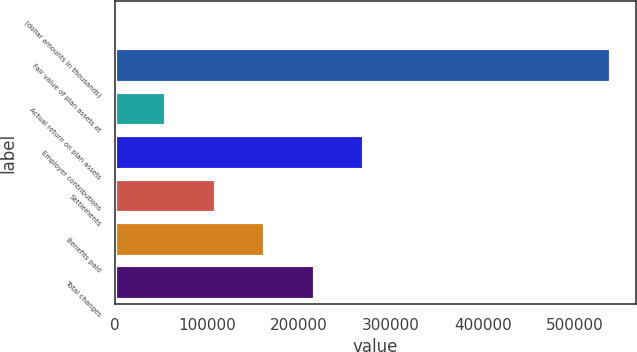Convert chart to OTSL. <chart><loc_0><loc_0><loc_500><loc_500><bar_chart><fcel>(dollar amounts in thousands)<fcel>Fair value of plan assets at<fcel>Actual return on plan assets<fcel>Employer contributions<fcel>Settlements<fcel>Benefits paid<fcel>Total changes<nl><fcel>2011<fcel>538970<fcel>55706.9<fcel>270490<fcel>109403<fcel>163099<fcel>216795<nl></chart> 